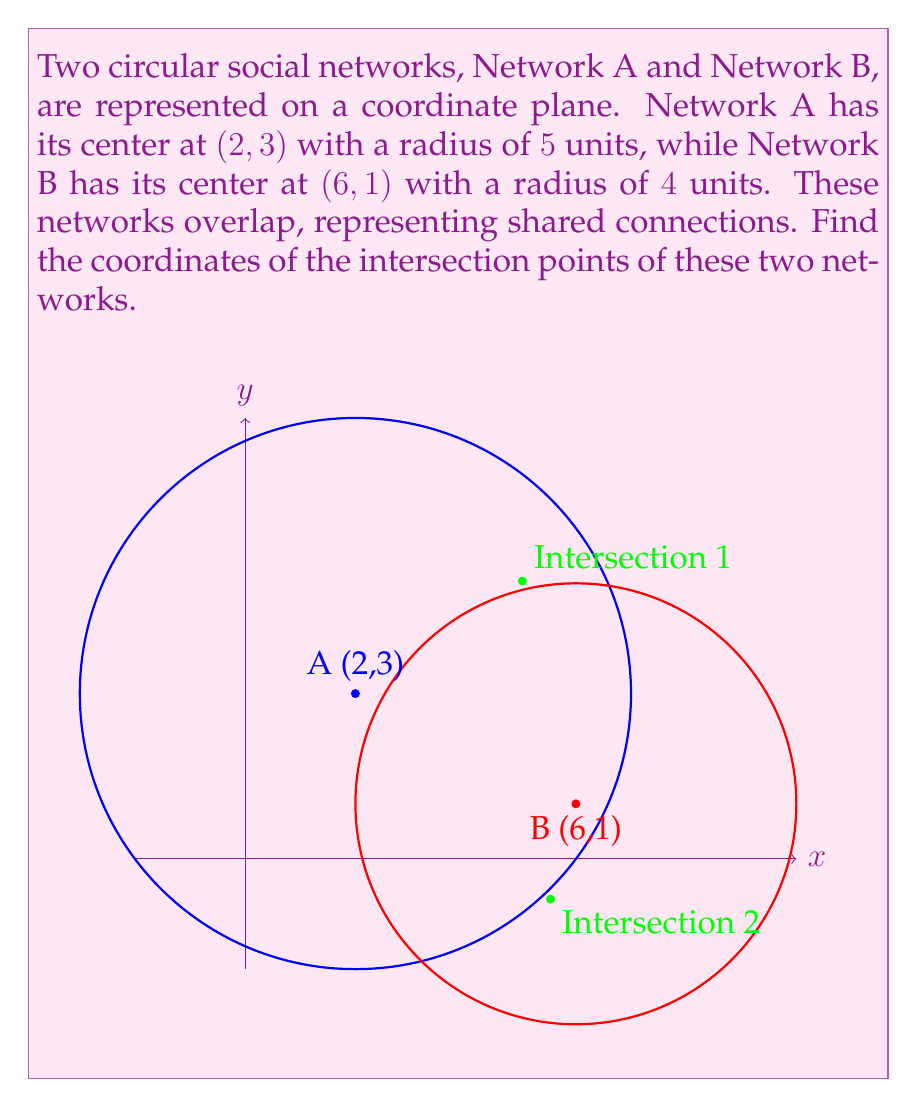Can you answer this question? To find the intersection points, we need to solve the system of equations representing these two circles:

1) For Network A: $$(x-2)^2 + (y-3)^2 = 5^2 = 25$$
2) For Network B: $$(x-6)^2 + (y-1)^2 = 4^2 = 16$$

Step 1: Expand the equations
1) $x^2 - 4x + 4 + y^2 - 6y + 9 = 25$
   $x^2 + y^2 - 4x - 6y - 12 = 0$
2) $x^2 - 12x + 36 + y^2 - 2y + 1 = 16$
   $x^2 + y^2 - 12x - 2y + 21 = 0$

Step 2: Subtract equation 1 from equation 2
$(-8x + 4y + 33) = 0$
$2x - y = \frac{33}{4}$

Step 3: Solve for y in terms of x
$y = 2x - \frac{33}{4}$

Step 4: Substitute this expression for y into equation 1
$x^2 + (2x - \frac{33}{4})^2 - 4x - 6(2x - \frac{33}{4}) - 12 = 0$

Step 5: Simplify and solve the resulting quadratic equation
$5x^2 - 22x + 20.390625 = 0$

Using the quadratic formula, we get:
$x = \frac{22 \pm \sqrt{484 - 4(5)(20.390625)}}{10}$

$x_1 \approx 5.43$ and $x_2 \approx 0.97$

Step 6: Calculate corresponding y values
$y_1 = 2(5.43) - \frac{33}{4} \approx 2.61$
$y_2 = 2(0.97) - \frac{33}{4} \approx -6.32$

Therefore, the intersection points are approximately (5.43, 2.61) and (0.97, -6.32).
Answer: (5.43, 2.61) and (0.97, -6.32) 